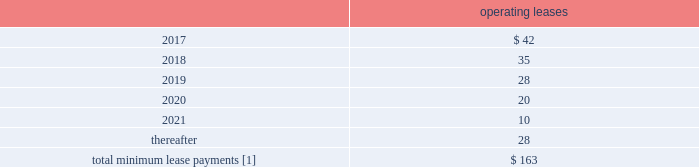F-80 www.thehartford.com the hartford financial services group , inc .
Notes to consolidated financial statements ( continued ) 14 .
Commitments and contingencies ( continued ) future minimum lease commitments as of december 31 , 2016 operating leases .
[1] excludes expected future minimum sublease income of approximately $ 2 , $ 2 , $ 2 , $ 2 , $ 0 and $ 0 in 2017 , 2018 , 2019 , 2020 , 2021 and thereafter respectively .
The company 2019s lease commitments consist primarily of lease agreements for office space , automobiles , and office equipment that expire at various dates .
Unfunded commitments as of december 31 , 2016 , the company has outstanding commitments totaling $ 1.6 billion , of which $ 1.2 billion is committed to fund limited partnership and other alternative investments , which may be called by the partnership during the commitment period to fund the purchase of new investments and partnership expenses .
Additionally , $ 313 of the outstanding commitments relate to various funding obligations associated with private placement securities .
The remaining outstanding commitments of $ 95 relate to mortgage loans the company is expecting to fund in the first half of 2017 .
Guaranty funds and other insurance-related assessments in all states , insurers licensed to transact certain classes of insurance are required to become members of a guaranty fund .
In most states , in the event of the insolvency of an insurer writing any such class of insurance in the state , the guaranty funds may assess its members to pay covered claims of the insolvent insurers .
Assessments are based on each member 2019s proportionate share of written premiums in the state for the classes of insurance in which the insolvent insurer was engaged .
Assessments are generally limited for any year to one or two percent of the premiums written per year depending on the state .
Some states permit member insurers to recover assessments paid through surcharges on policyholders or through full or partial premium tax offsets , while other states permit recovery of assessments through the rate filing process .
Liabilities for guaranty fund and other insurance-related assessments are accrued when an assessment is probable , when it can be reasonably estimated , and when the event obligating the company to pay an imposed or probable assessment has occurred .
Liabilities for guaranty funds and other insurance- related assessments are not discounted and are included as part of other liabilities in the consolidated balance sheets .
As of december 31 , 2016 and 2015 the liability balance was $ 134 and $ 138 , respectively .
As of december 31 , 2016 and 2015 amounts related to premium tax offsets of $ 34 and $ 44 , respectively , were included in other assets .
Derivative commitments certain of the company 2019s derivative agreements contain provisions that are tied to the financial strength ratings , as set by nationally recognized statistical agencies , of the individual legal entity that entered into the derivative agreement .
If the legal entity 2019s financial strength were to fall below certain ratings , the counterparties to the derivative agreements could demand immediate and ongoing full collateralization and in certain instances enable the counterparties to terminate the agreements and demand immediate settlement of all outstanding derivative positions traded under each impacted bilateral agreement .
The settlement amount is determined by netting the derivative positions transacted under each agreement .
If the termination rights were to be exercised by the counterparties , it could impact the legal entity 2019s ability to conduct hedging activities by increasing the associated costs and decreasing the willingness of counterparties to transact with the legal entity .
The aggregate fair value of all derivative instruments with credit-risk-related contingent features that are in a net liability position as of december 31 , 2016 was $ 1.4 billion .
Of this $ 1.4 billion , the legal entities have posted collateral of $ 1.7 billion in the normal course of business .
In addition , the company has posted collateral of $ 31 associated with a customized gmwb derivative .
Based on derivative market values as of december 31 , 2016 , a downgrade of one level below the current financial strength ratings by either moody 2019s or s&p would not require additional assets to be posted as collateral .
Based on derivative market values as of december 31 , 2016 , a downgrade of two levels below the current financial strength ratings by either moody 2019s or s&p would require additional $ 10 of assets to be posted as collateral .
These collateral amounts could change as derivative market values change , as a result of changes in our hedging activities or to the extent changes in contractual terms are negotiated .
The nature of the collateral that we post , when required , is primarily in the form of u.s .
Treasury bills , u.s .
Treasury notes and government agency securities .
Guarantees in the ordinary course of selling businesses or entities to third parties , the company has agreed to indemnify purchasers for losses arising subsequent to the closing due to breaches of representations and warranties with respect to the business or entity being sold or with respect to covenants and obligations of the company and/or its subsidiaries .
These obligations are typically subject to various time limitations , defined by the contract or by operation of law , such as statutes of limitation .
In some cases , the maximum potential obligation is subject to contractual limitations , while in other cases such limitations are not specified or applicable .
The company does not expect to make any payments on these guarantees and is not carrying any liabilities associated with these guarantees. .
What is the total future expected income from subleases? 
Computations: (((2 + 2) + 2) + 2)
Answer: 8.0. 